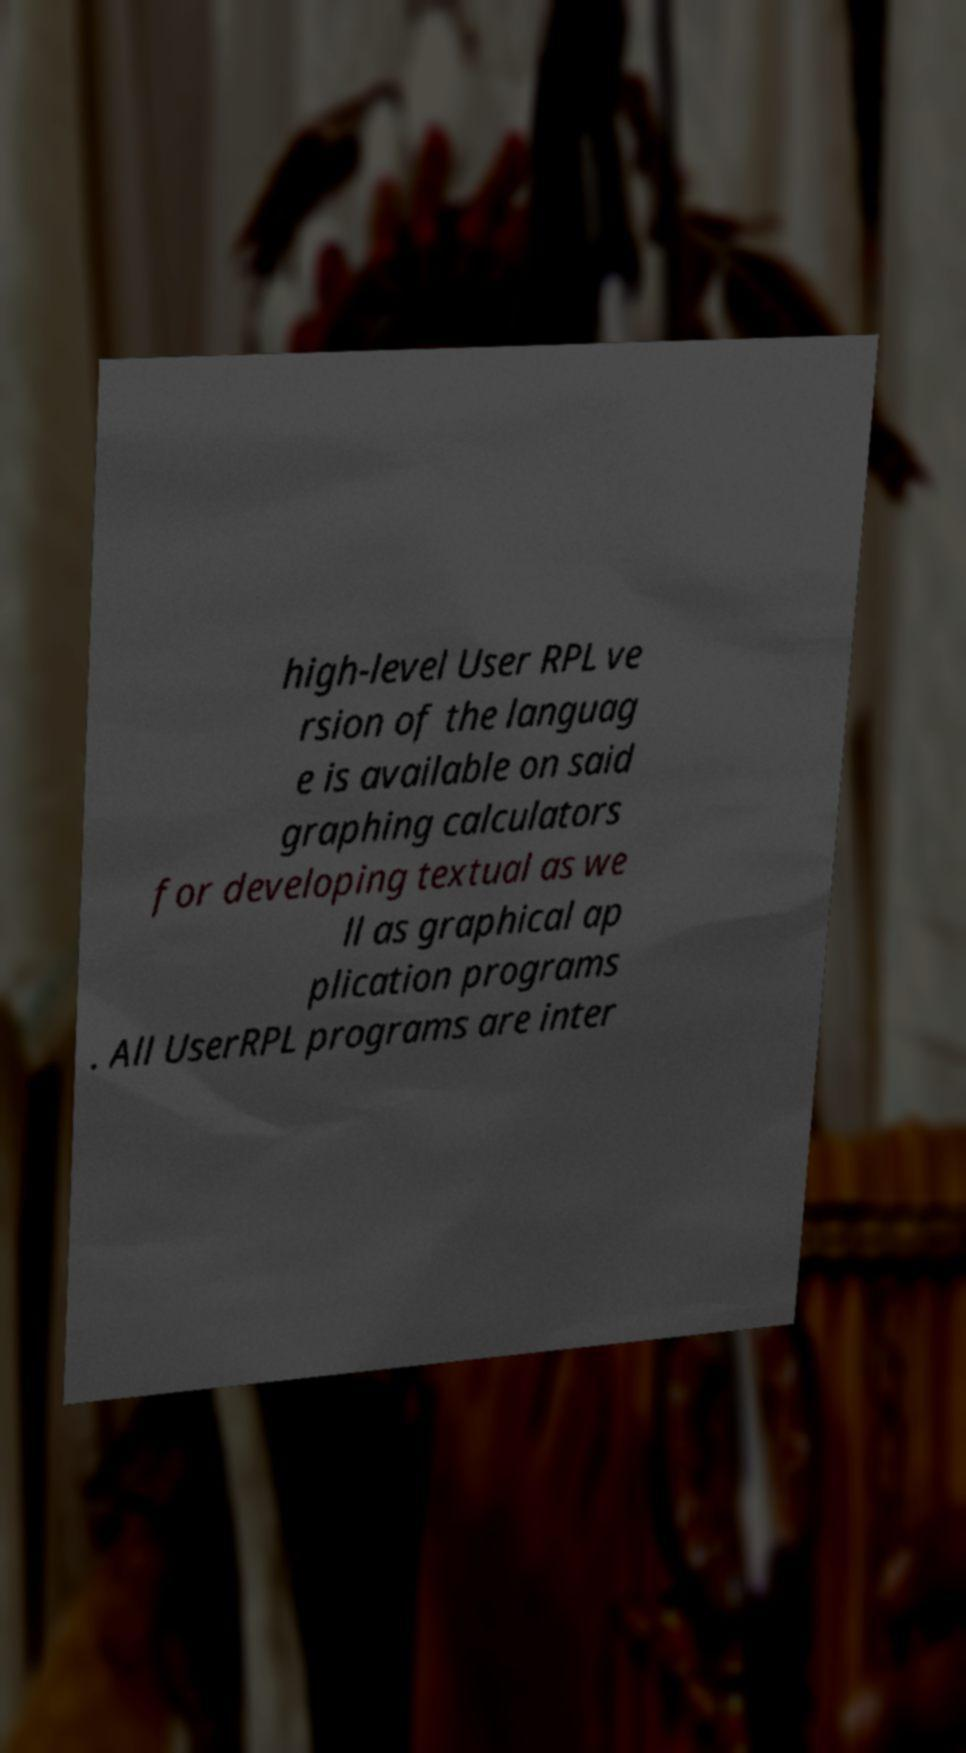Please identify and transcribe the text found in this image. high-level User RPL ve rsion of the languag e is available on said graphing calculators for developing textual as we ll as graphical ap plication programs . All UserRPL programs are inter 